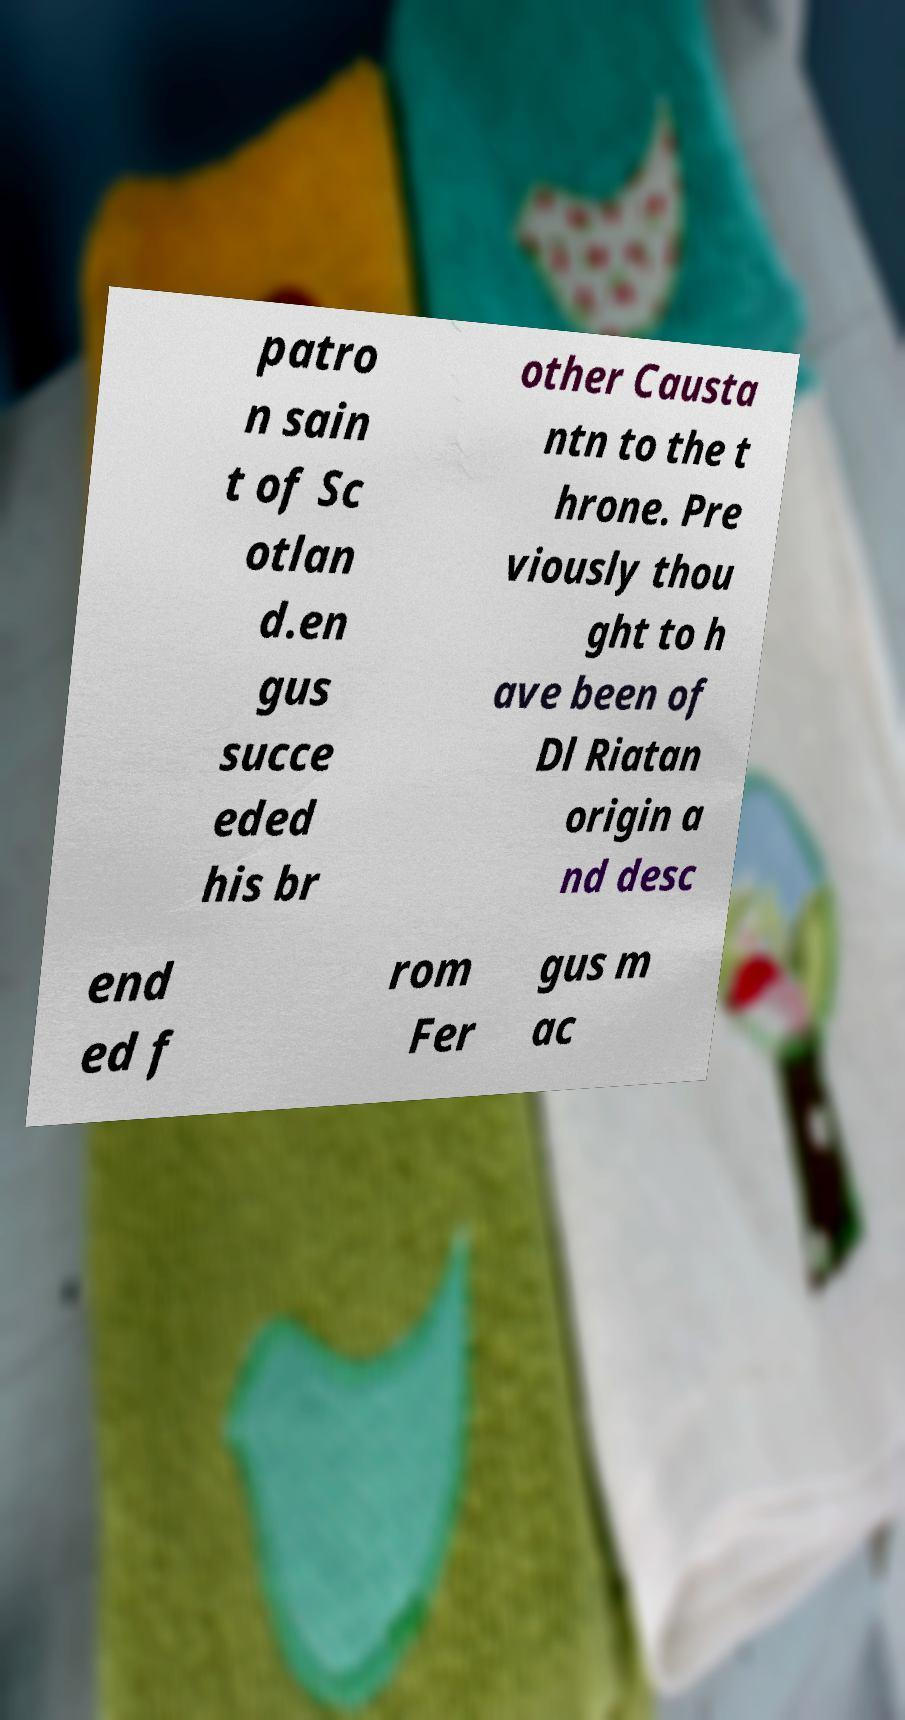What messages or text are displayed in this image? I need them in a readable, typed format. patro n sain t of Sc otlan d.en gus succe eded his br other Causta ntn to the t hrone. Pre viously thou ght to h ave been of Dl Riatan origin a nd desc end ed f rom Fer gus m ac 